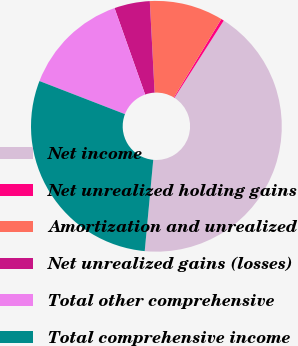Convert chart. <chart><loc_0><loc_0><loc_500><loc_500><pie_chart><fcel>Net income<fcel>Net unrealized holding gains<fcel>Amortization and unrealized<fcel>Net unrealized gains (losses)<fcel>Total other comprehensive<fcel>Total comprehensive income<nl><fcel>42.46%<fcel>0.37%<fcel>9.5%<fcel>4.58%<fcel>13.71%<fcel>29.4%<nl></chart> 